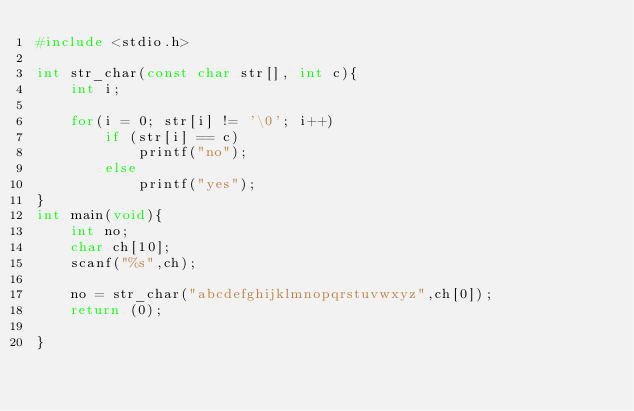Convert code to text. <code><loc_0><loc_0><loc_500><loc_500><_C_>#include <stdio.h>

int str_char(const char str[], int c){
	int i;

	for(i = 0; str[i] != '\0'; i++)
		if (str[i] == c)
			printf("no");
		else
			printf("yes");
}
int main(void){
	int no;
	char ch[10];
	scanf("%s",ch);

	no = str_char("abcdefghijklmnopqrstuvwxyz",ch[0]);
	return (0);

}</code> 